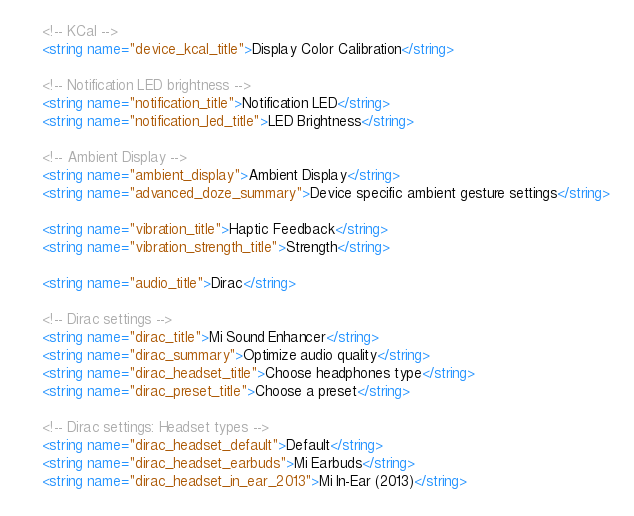Convert code to text. <code><loc_0><loc_0><loc_500><loc_500><_XML_>    <!-- KCal -->
    <string name="device_kcal_title">Display Color Calibration</string>

    <!-- Notification LED brightness -->
    <string name="notification_title">Notification LED</string>
    <string name="notification_led_title">LED Brightness</string>

    <!-- Ambient Display -->
    <string name="ambient_display">Ambient Display</string>
    <string name="advanced_doze_summary">Device specific ambient gesture settings</string>

    <string name="vibration_title">Haptic Feedback</string>
    <string name="vibration_strength_title">Strength</string>

    <string name="audio_title">Dirac</string>

    <!-- Dirac settings -->
    <string name="dirac_title">Mi Sound Enhancer</string>
    <string name="dirac_summary">Optimize audio quality</string>
    <string name="dirac_headset_title">Choose headphones type</string>
    <string name="dirac_preset_title">Choose a preset</string>

    <!-- Dirac settings: Headset types -->
    <string name="dirac_headset_default">Default</string>
    <string name="dirac_headset_earbuds">Mi Earbuds</string>
    <string name="dirac_headset_in_ear_2013">Mi In-Ear (2013)</string></code> 